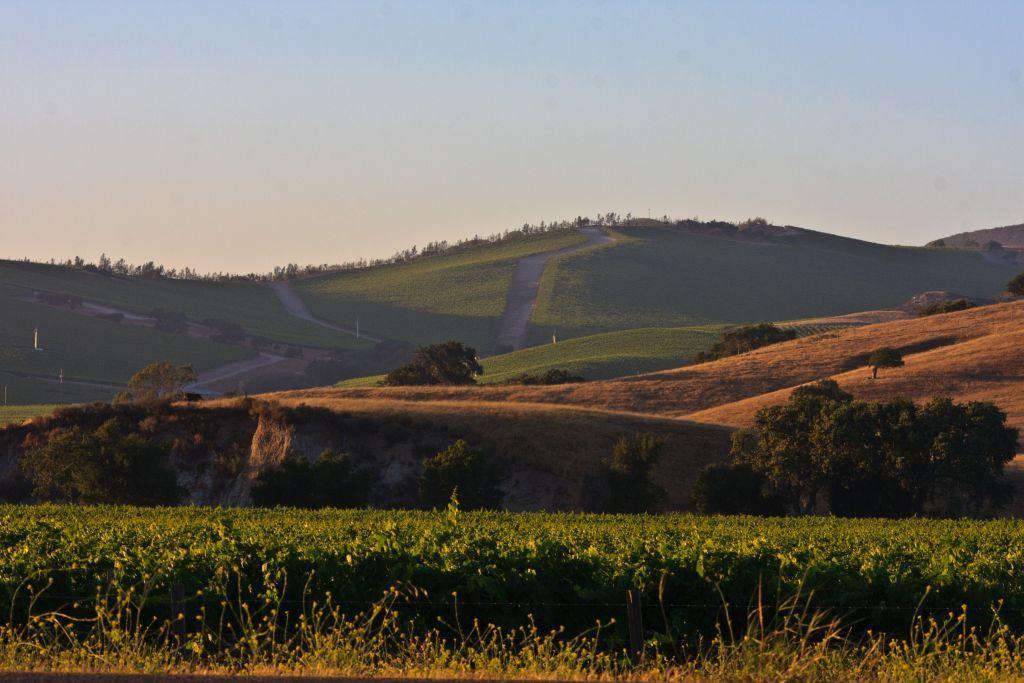Can you describe this image briefly? In this image we can see the hills, trees and also the plants. We can also see the sky. 